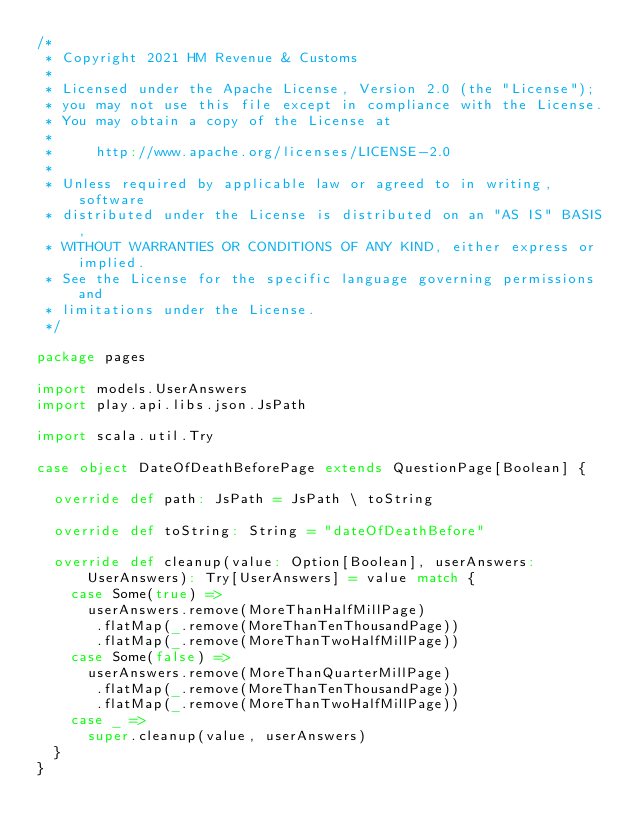Convert code to text. <code><loc_0><loc_0><loc_500><loc_500><_Scala_>/*
 * Copyright 2021 HM Revenue & Customs
 *
 * Licensed under the Apache License, Version 2.0 (the "License");
 * you may not use this file except in compliance with the License.
 * You may obtain a copy of the License at
 *
 *     http://www.apache.org/licenses/LICENSE-2.0
 *
 * Unless required by applicable law or agreed to in writing, software
 * distributed under the License is distributed on an "AS IS" BASIS,
 * WITHOUT WARRANTIES OR CONDITIONS OF ANY KIND, either express or implied.
 * See the License for the specific language governing permissions and
 * limitations under the License.
 */

package pages

import models.UserAnswers
import play.api.libs.json.JsPath

import scala.util.Try

case object DateOfDeathBeforePage extends QuestionPage[Boolean] {

  override def path: JsPath = JsPath \ toString

  override def toString: String = "dateOfDeathBefore"

  override def cleanup(value: Option[Boolean], userAnswers: UserAnswers): Try[UserAnswers] = value match {
    case Some(true) =>
      userAnswers.remove(MoreThanHalfMillPage)
       .flatMap(_.remove(MoreThanTenThousandPage))
       .flatMap(_.remove(MoreThanTwoHalfMillPage))
    case Some(false) =>
      userAnswers.remove(MoreThanQuarterMillPage)
       .flatMap(_.remove(MoreThanTenThousandPage))
       .flatMap(_.remove(MoreThanTwoHalfMillPage))
    case _ =>
      super.cleanup(value, userAnswers)
  }
}
</code> 